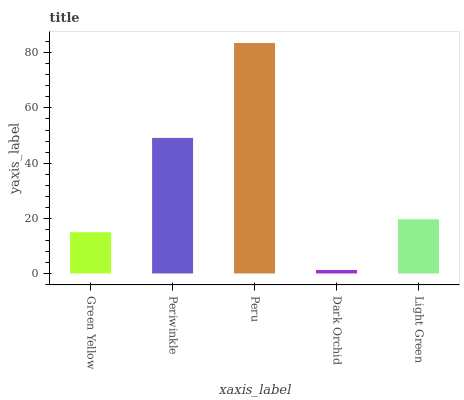Is Dark Orchid the minimum?
Answer yes or no. Yes. Is Peru the maximum?
Answer yes or no. Yes. Is Periwinkle the minimum?
Answer yes or no. No. Is Periwinkle the maximum?
Answer yes or no. No. Is Periwinkle greater than Green Yellow?
Answer yes or no. Yes. Is Green Yellow less than Periwinkle?
Answer yes or no. Yes. Is Green Yellow greater than Periwinkle?
Answer yes or no. No. Is Periwinkle less than Green Yellow?
Answer yes or no. No. Is Light Green the high median?
Answer yes or no. Yes. Is Light Green the low median?
Answer yes or no. Yes. Is Peru the high median?
Answer yes or no. No. Is Green Yellow the low median?
Answer yes or no. No. 